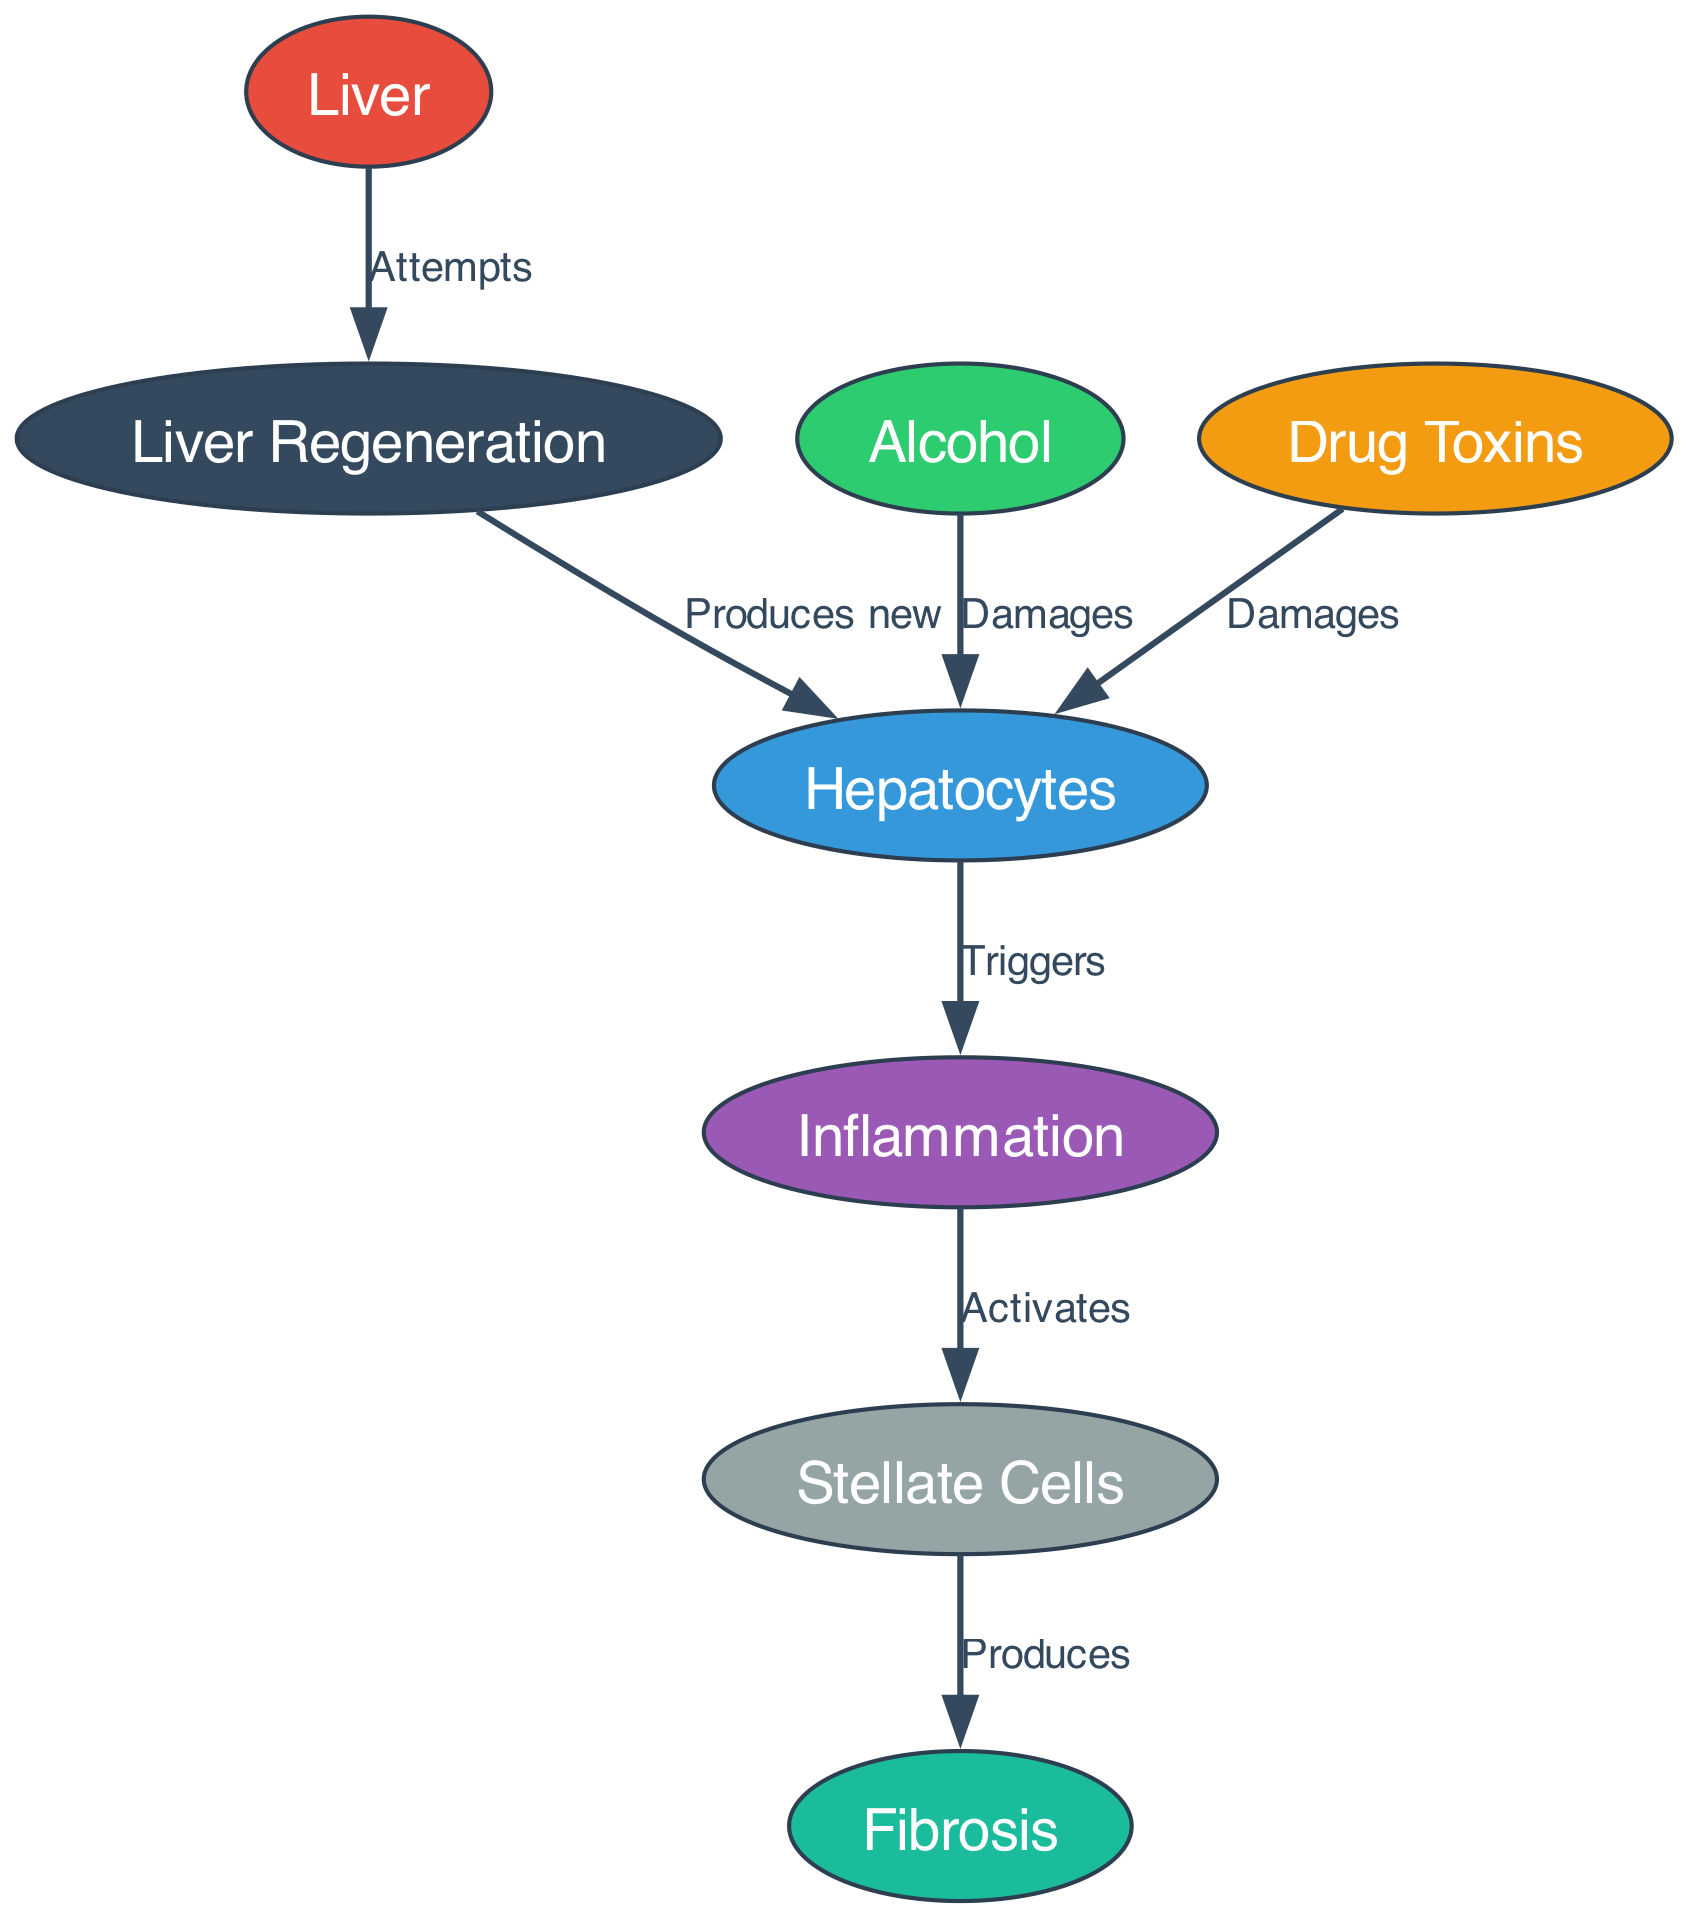What triggers inflammation in the liver? According to the diagram, inflammation is triggered by hepatocytes, which are damaged by both alcohol and drug toxins. Therefore, hepatocytes play a crucial role in initiating the inflammation response following injury.
Answer: Hepatocytes How many nodes are in the diagram? By counting the unique elements represented in the diagram, we find there are a total of 8 nodes: Liver, Hepatocytes, Alcohol, Drug Toxins, Inflammation, Fibrosis, Liver Regeneration, and Stellate Cells.
Answer: 8 What do stellate cells produce? The diagram explicitly states that stellate cells produce fibrosis, indicating their role in the liver damage process following inflammation.
Answer: Fibrosis What attempts liver regeneration? The diagram connects the liver to liver regeneration, indicating that the liver itself is responsible for attempting regeneration in response to damage.
Answer: Liver How does inflammation affect stellate cells? The diagram shows that inflammation activates stellate cells, demonstrating how the inflammatory response leads to changes in these cells, which are involved in fibrosis development.
Answer: Activates What damages hepatocytes? The diagram illustrates that hepatocytes are damaged by both alcohol and drug toxins, highlighting the impact of substance abuse on liver cell health.
Answer: Alcohol, Drug Toxins What connects liver regeneration back to hepatocytes? In the diagram, liver regeneration produces new hepatocytes, showing the process of how the liver repairs itself by generating new hepatocyte cells after damage has occurred.
Answer: Produces new What is the final outcome after the liver attempts regeneration? The diagram illustrates that the liver attempts regeneration, which ultimately leads to the production of new hepatocytes, demonstrating the compensatory processes of the liver following injury.
Answer: New hepatocytes 